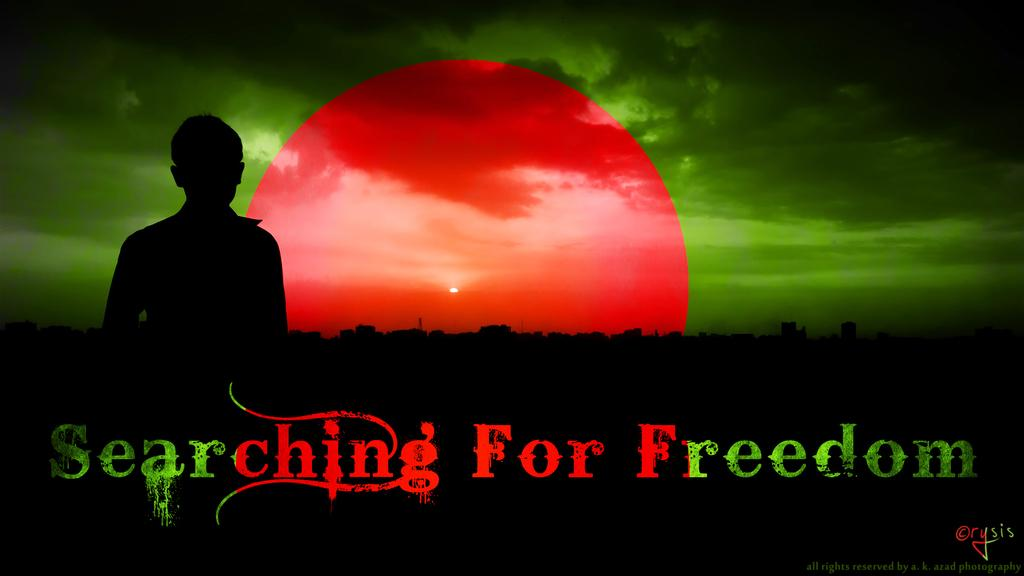<image>
Describe the image concisely. a green and blue photo that says 'searching for freedom' 